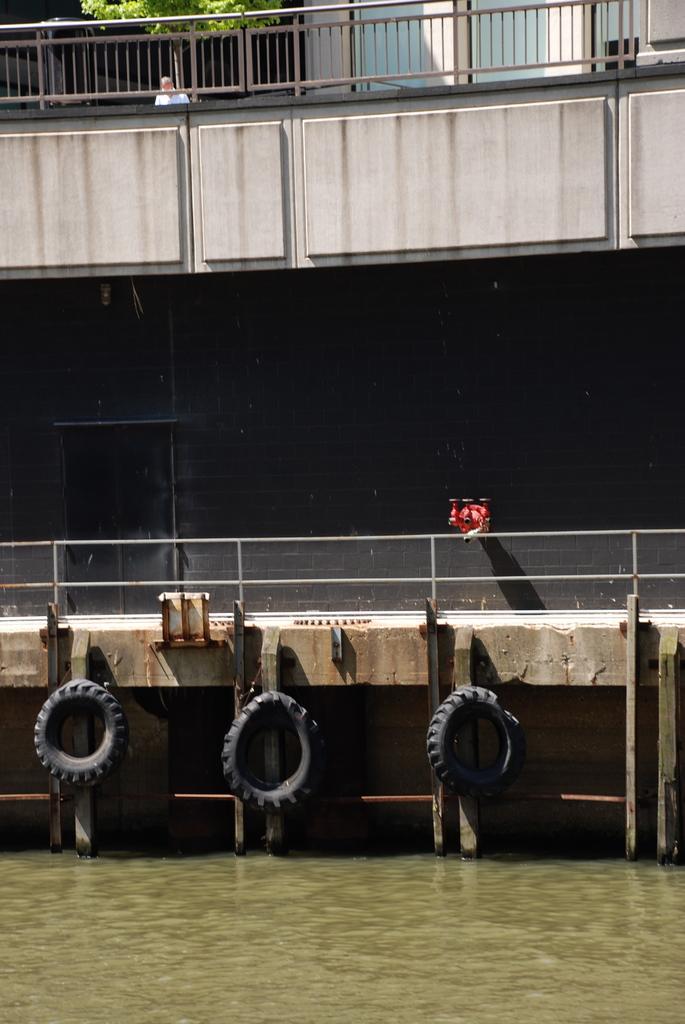In one or two sentences, can you explain what this image depicts? In the foreground of this image, at the bottom, there is water. In the middle, there is railing, few tyres, wall and a red color object on the wall. At the top, there is a railing, a tree, wall and a person. 